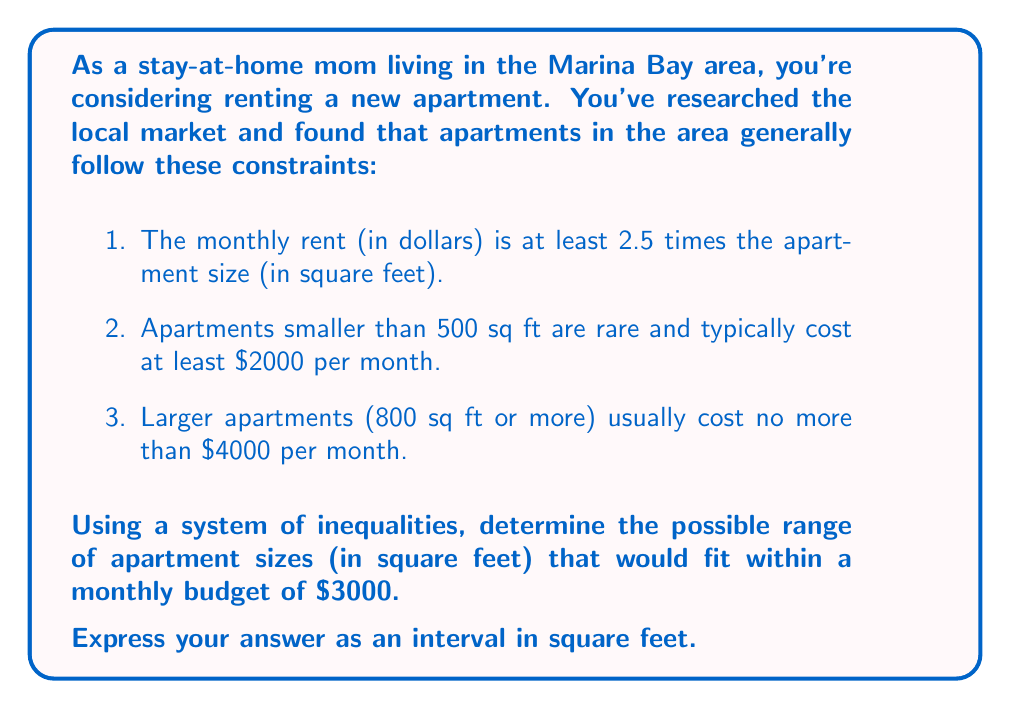Solve this math problem. Let's approach this step-by-step using a system of inequalities:

1. Let $x$ be the apartment size in square feet and $y$ be the monthly rent in dollars.

2. From the given constraints, we can form the following inequalities:

   a) $y \geq 2.5x$ (rent is at least 2.5 times the size)
   b) If $x < 500$, then $y \geq 2000$ (small apartments cost at least $2000)
   c) If $x \geq 800$, then $y \leq 4000$ (large apartments cost no more than $4000)

3. We're looking for apartments that cost $3000 per month, so we set $y = 3000$.

4. Substituting this into the first inequality:
   
   $3000 \geq 2.5x$
   $1200 \geq x$

5. Now, we need to consider the other constraints:

   a) If $x < 500$, $y$ must be at least $2000. This is satisfied since $y = 3000$.
   b) If $x \geq 800$, $y$ must be at most $4000. This is also satisfied since $y = 3000$.

6. Therefore, our only constraint on $x$ is that it must be less than or equal to 1200 sq ft.

7. For the lower bound, we use the fact that rent is at least 2.5 times the size:

   $3000 \geq 2.5x$
   $1200 \geq x$

   So the minimum size is 1200 sq ft.

8. Combining these results, we get:

   $500 \leq x \leq 1200$
Answer: The possible range of apartment sizes within a $3000 monthly budget is $[500, 1200]$ square feet. 